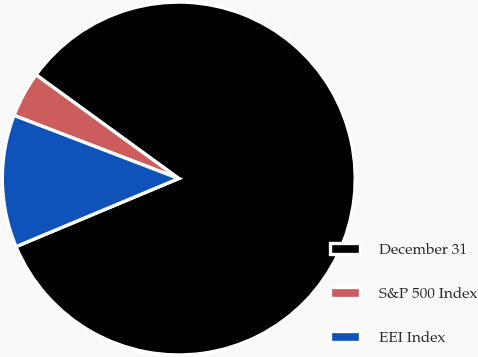<chart> <loc_0><loc_0><loc_500><loc_500><pie_chart><fcel>December 31<fcel>S&P 500 Index<fcel>EEI Index<nl><fcel>83.69%<fcel>4.18%<fcel>12.13%<nl></chart> 